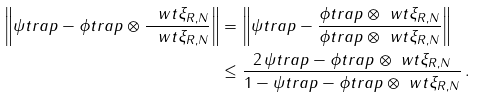<formula> <loc_0><loc_0><loc_500><loc_500>\left \| \psi t r a p - \phi t r a p \otimes \frac { \ w t \xi _ { R , N } } { \| \ w t \xi _ { R , N } \| } \right \| & = \left \| \psi t r a p - \frac { \phi t r a p \otimes \ w t \xi _ { R , N } } { \| \phi t r a p \otimes \ w t \xi _ { R , N } \| } \right \| \\ & \leq \frac { 2 \, \| \psi t r a p - \phi t r a p \otimes \ w t \xi _ { R , N } \| } { 1 - \| \psi t r a p - \phi t r a p \otimes \ w t \xi _ { R , N } \| } \, .</formula> 